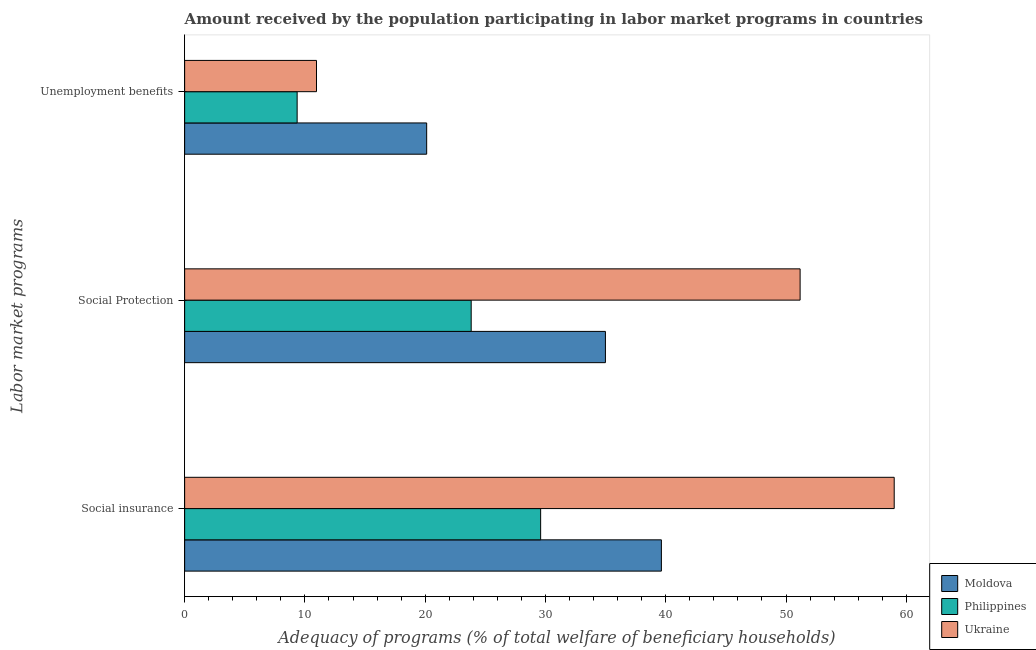How many different coloured bars are there?
Ensure brevity in your answer.  3. Are the number of bars on each tick of the Y-axis equal?
Give a very brief answer. Yes. What is the label of the 1st group of bars from the top?
Give a very brief answer. Unemployment benefits. What is the amount received by the population participating in unemployment benefits programs in Moldova?
Your answer should be compact. 20.12. Across all countries, what is the maximum amount received by the population participating in social insurance programs?
Provide a short and direct response. 58.99. Across all countries, what is the minimum amount received by the population participating in social protection programs?
Offer a very short reply. 23.82. In which country was the amount received by the population participating in social protection programs maximum?
Keep it short and to the point. Ukraine. What is the total amount received by the population participating in social insurance programs in the graph?
Your answer should be compact. 128.23. What is the difference between the amount received by the population participating in unemployment benefits programs in Moldova and that in Ukraine?
Keep it short and to the point. 9.16. What is the difference between the amount received by the population participating in social protection programs in Moldova and the amount received by the population participating in social insurance programs in Philippines?
Your answer should be very brief. 5.39. What is the average amount received by the population participating in social insurance programs per country?
Your answer should be very brief. 42.74. What is the difference between the amount received by the population participating in unemployment benefits programs and amount received by the population participating in social protection programs in Moldova?
Offer a terse response. -14.86. What is the ratio of the amount received by the population participating in social insurance programs in Philippines to that in Moldova?
Give a very brief answer. 0.75. What is the difference between the highest and the second highest amount received by the population participating in unemployment benefits programs?
Your answer should be very brief. 9.16. What is the difference between the highest and the lowest amount received by the population participating in unemployment benefits programs?
Your answer should be very brief. 10.77. In how many countries, is the amount received by the population participating in social insurance programs greater than the average amount received by the population participating in social insurance programs taken over all countries?
Offer a very short reply. 1. What does the 2nd bar from the top in Social insurance represents?
Ensure brevity in your answer.  Philippines. What does the 2nd bar from the bottom in Unemployment benefits represents?
Make the answer very short. Philippines. Does the graph contain any zero values?
Your answer should be very brief. No. What is the title of the graph?
Make the answer very short. Amount received by the population participating in labor market programs in countries. What is the label or title of the X-axis?
Offer a terse response. Adequacy of programs (% of total welfare of beneficiary households). What is the label or title of the Y-axis?
Offer a terse response. Labor market programs. What is the Adequacy of programs (% of total welfare of beneficiary households) in Moldova in Social insurance?
Keep it short and to the point. 39.64. What is the Adequacy of programs (% of total welfare of beneficiary households) of Philippines in Social insurance?
Give a very brief answer. 29.6. What is the Adequacy of programs (% of total welfare of beneficiary households) in Ukraine in Social insurance?
Give a very brief answer. 58.99. What is the Adequacy of programs (% of total welfare of beneficiary households) in Moldova in Social Protection?
Provide a succinct answer. 34.98. What is the Adequacy of programs (% of total welfare of beneficiary households) in Philippines in Social Protection?
Provide a succinct answer. 23.82. What is the Adequacy of programs (% of total welfare of beneficiary households) in Ukraine in Social Protection?
Provide a short and direct response. 51.17. What is the Adequacy of programs (% of total welfare of beneficiary households) of Moldova in Unemployment benefits?
Offer a terse response. 20.12. What is the Adequacy of programs (% of total welfare of beneficiary households) in Philippines in Unemployment benefits?
Your response must be concise. 9.35. What is the Adequacy of programs (% of total welfare of beneficiary households) of Ukraine in Unemployment benefits?
Offer a terse response. 10.96. Across all Labor market programs, what is the maximum Adequacy of programs (% of total welfare of beneficiary households) of Moldova?
Offer a terse response. 39.64. Across all Labor market programs, what is the maximum Adequacy of programs (% of total welfare of beneficiary households) of Philippines?
Your response must be concise. 29.6. Across all Labor market programs, what is the maximum Adequacy of programs (% of total welfare of beneficiary households) in Ukraine?
Keep it short and to the point. 58.99. Across all Labor market programs, what is the minimum Adequacy of programs (% of total welfare of beneficiary households) in Moldova?
Your answer should be compact. 20.12. Across all Labor market programs, what is the minimum Adequacy of programs (% of total welfare of beneficiary households) in Philippines?
Your answer should be compact. 9.35. Across all Labor market programs, what is the minimum Adequacy of programs (% of total welfare of beneficiary households) of Ukraine?
Offer a terse response. 10.96. What is the total Adequacy of programs (% of total welfare of beneficiary households) of Moldova in the graph?
Your answer should be very brief. 94.75. What is the total Adequacy of programs (% of total welfare of beneficiary households) of Philippines in the graph?
Your answer should be compact. 62.78. What is the total Adequacy of programs (% of total welfare of beneficiary households) in Ukraine in the graph?
Your answer should be compact. 121.13. What is the difference between the Adequacy of programs (% of total welfare of beneficiary households) in Moldova in Social insurance and that in Social Protection?
Offer a terse response. 4.65. What is the difference between the Adequacy of programs (% of total welfare of beneficiary households) of Philippines in Social insurance and that in Social Protection?
Offer a terse response. 5.78. What is the difference between the Adequacy of programs (% of total welfare of beneficiary households) in Ukraine in Social insurance and that in Social Protection?
Provide a succinct answer. 7.82. What is the difference between the Adequacy of programs (% of total welfare of beneficiary households) of Moldova in Social insurance and that in Unemployment benefits?
Provide a short and direct response. 19.52. What is the difference between the Adequacy of programs (% of total welfare of beneficiary households) in Philippines in Social insurance and that in Unemployment benefits?
Your response must be concise. 20.25. What is the difference between the Adequacy of programs (% of total welfare of beneficiary households) in Ukraine in Social insurance and that in Unemployment benefits?
Make the answer very short. 48.03. What is the difference between the Adequacy of programs (% of total welfare of beneficiary households) of Moldova in Social Protection and that in Unemployment benefits?
Provide a succinct answer. 14.86. What is the difference between the Adequacy of programs (% of total welfare of beneficiary households) of Philippines in Social Protection and that in Unemployment benefits?
Provide a succinct answer. 14.47. What is the difference between the Adequacy of programs (% of total welfare of beneficiary households) of Ukraine in Social Protection and that in Unemployment benefits?
Give a very brief answer. 40.21. What is the difference between the Adequacy of programs (% of total welfare of beneficiary households) in Moldova in Social insurance and the Adequacy of programs (% of total welfare of beneficiary households) in Philippines in Social Protection?
Provide a succinct answer. 15.81. What is the difference between the Adequacy of programs (% of total welfare of beneficiary households) of Moldova in Social insurance and the Adequacy of programs (% of total welfare of beneficiary households) of Ukraine in Social Protection?
Your answer should be compact. -11.53. What is the difference between the Adequacy of programs (% of total welfare of beneficiary households) of Philippines in Social insurance and the Adequacy of programs (% of total welfare of beneficiary households) of Ukraine in Social Protection?
Your response must be concise. -21.57. What is the difference between the Adequacy of programs (% of total welfare of beneficiary households) of Moldova in Social insurance and the Adequacy of programs (% of total welfare of beneficiary households) of Philippines in Unemployment benefits?
Make the answer very short. 30.28. What is the difference between the Adequacy of programs (% of total welfare of beneficiary households) of Moldova in Social insurance and the Adequacy of programs (% of total welfare of beneficiary households) of Ukraine in Unemployment benefits?
Offer a very short reply. 28.68. What is the difference between the Adequacy of programs (% of total welfare of beneficiary households) in Philippines in Social insurance and the Adequacy of programs (% of total welfare of beneficiary households) in Ukraine in Unemployment benefits?
Ensure brevity in your answer.  18.64. What is the difference between the Adequacy of programs (% of total welfare of beneficiary households) in Moldova in Social Protection and the Adequacy of programs (% of total welfare of beneficiary households) in Philippines in Unemployment benefits?
Provide a succinct answer. 25.63. What is the difference between the Adequacy of programs (% of total welfare of beneficiary households) of Moldova in Social Protection and the Adequacy of programs (% of total welfare of beneficiary households) of Ukraine in Unemployment benefits?
Offer a terse response. 24.02. What is the difference between the Adequacy of programs (% of total welfare of beneficiary households) in Philippines in Social Protection and the Adequacy of programs (% of total welfare of beneficiary households) in Ukraine in Unemployment benefits?
Ensure brevity in your answer.  12.86. What is the average Adequacy of programs (% of total welfare of beneficiary households) of Moldova per Labor market programs?
Provide a short and direct response. 31.58. What is the average Adequacy of programs (% of total welfare of beneficiary households) in Philippines per Labor market programs?
Your answer should be compact. 20.93. What is the average Adequacy of programs (% of total welfare of beneficiary households) in Ukraine per Labor market programs?
Offer a terse response. 40.38. What is the difference between the Adequacy of programs (% of total welfare of beneficiary households) in Moldova and Adequacy of programs (% of total welfare of beneficiary households) in Philippines in Social insurance?
Ensure brevity in your answer.  10.04. What is the difference between the Adequacy of programs (% of total welfare of beneficiary households) of Moldova and Adequacy of programs (% of total welfare of beneficiary households) of Ukraine in Social insurance?
Provide a short and direct response. -19.36. What is the difference between the Adequacy of programs (% of total welfare of beneficiary households) in Philippines and Adequacy of programs (% of total welfare of beneficiary households) in Ukraine in Social insurance?
Keep it short and to the point. -29.4. What is the difference between the Adequacy of programs (% of total welfare of beneficiary households) in Moldova and Adequacy of programs (% of total welfare of beneficiary households) in Philippines in Social Protection?
Ensure brevity in your answer.  11.16. What is the difference between the Adequacy of programs (% of total welfare of beneficiary households) in Moldova and Adequacy of programs (% of total welfare of beneficiary households) in Ukraine in Social Protection?
Make the answer very short. -16.19. What is the difference between the Adequacy of programs (% of total welfare of beneficiary households) in Philippines and Adequacy of programs (% of total welfare of beneficiary households) in Ukraine in Social Protection?
Your answer should be very brief. -27.35. What is the difference between the Adequacy of programs (% of total welfare of beneficiary households) in Moldova and Adequacy of programs (% of total welfare of beneficiary households) in Philippines in Unemployment benefits?
Ensure brevity in your answer.  10.77. What is the difference between the Adequacy of programs (% of total welfare of beneficiary households) of Moldova and Adequacy of programs (% of total welfare of beneficiary households) of Ukraine in Unemployment benefits?
Ensure brevity in your answer.  9.16. What is the difference between the Adequacy of programs (% of total welfare of beneficiary households) of Philippines and Adequacy of programs (% of total welfare of beneficiary households) of Ukraine in Unemployment benefits?
Your answer should be compact. -1.61. What is the ratio of the Adequacy of programs (% of total welfare of beneficiary households) of Moldova in Social insurance to that in Social Protection?
Offer a very short reply. 1.13. What is the ratio of the Adequacy of programs (% of total welfare of beneficiary households) of Philippines in Social insurance to that in Social Protection?
Offer a very short reply. 1.24. What is the ratio of the Adequacy of programs (% of total welfare of beneficiary households) in Ukraine in Social insurance to that in Social Protection?
Your response must be concise. 1.15. What is the ratio of the Adequacy of programs (% of total welfare of beneficiary households) in Moldova in Social insurance to that in Unemployment benefits?
Make the answer very short. 1.97. What is the ratio of the Adequacy of programs (% of total welfare of beneficiary households) of Philippines in Social insurance to that in Unemployment benefits?
Offer a very short reply. 3.16. What is the ratio of the Adequacy of programs (% of total welfare of beneficiary households) of Ukraine in Social insurance to that in Unemployment benefits?
Keep it short and to the point. 5.38. What is the ratio of the Adequacy of programs (% of total welfare of beneficiary households) in Moldova in Social Protection to that in Unemployment benefits?
Your answer should be very brief. 1.74. What is the ratio of the Adequacy of programs (% of total welfare of beneficiary households) of Philippines in Social Protection to that in Unemployment benefits?
Offer a very short reply. 2.55. What is the ratio of the Adequacy of programs (% of total welfare of beneficiary households) of Ukraine in Social Protection to that in Unemployment benefits?
Your answer should be very brief. 4.67. What is the difference between the highest and the second highest Adequacy of programs (% of total welfare of beneficiary households) of Moldova?
Your answer should be compact. 4.65. What is the difference between the highest and the second highest Adequacy of programs (% of total welfare of beneficiary households) in Philippines?
Provide a succinct answer. 5.78. What is the difference between the highest and the second highest Adequacy of programs (% of total welfare of beneficiary households) of Ukraine?
Offer a terse response. 7.82. What is the difference between the highest and the lowest Adequacy of programs (% of total welfare of beneficiary households) of Moldova?
Your answer should be compact. 19.52. What is the difference between the highest and the lowest Adequacy of programs (% of total welfare of beneficiary households) of Philippines?
Your answer should be compact. 20.25. What is the difference between the highest and the lowest Adequacy of programs (% of total welfare of beneficiary households) in Ukraine?
Keep it short and to the point. 48.03. 